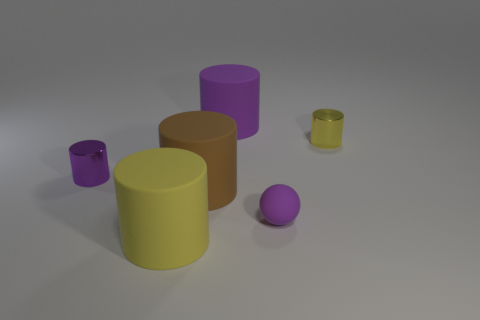What is the material of the yellow object that is the same size as the purple matte ball? The yellow object that matches the size of the purple ball appears to have a smooth, reflective surface suggesting it could be made of a polished metal or a similarly reflective material. 